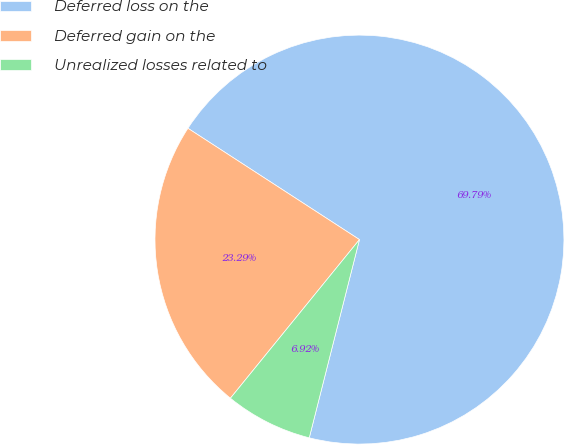<chart> <loc_0><loc_0><loc_500><loc_500><pie_chart><fcel>Deferred loss on the<fcel>Deferred gain on the<fcel>Unrealized losses related to<nl><fcel>69.78%<fcel>23.29%<fcel>6.92%<nl></chart> 